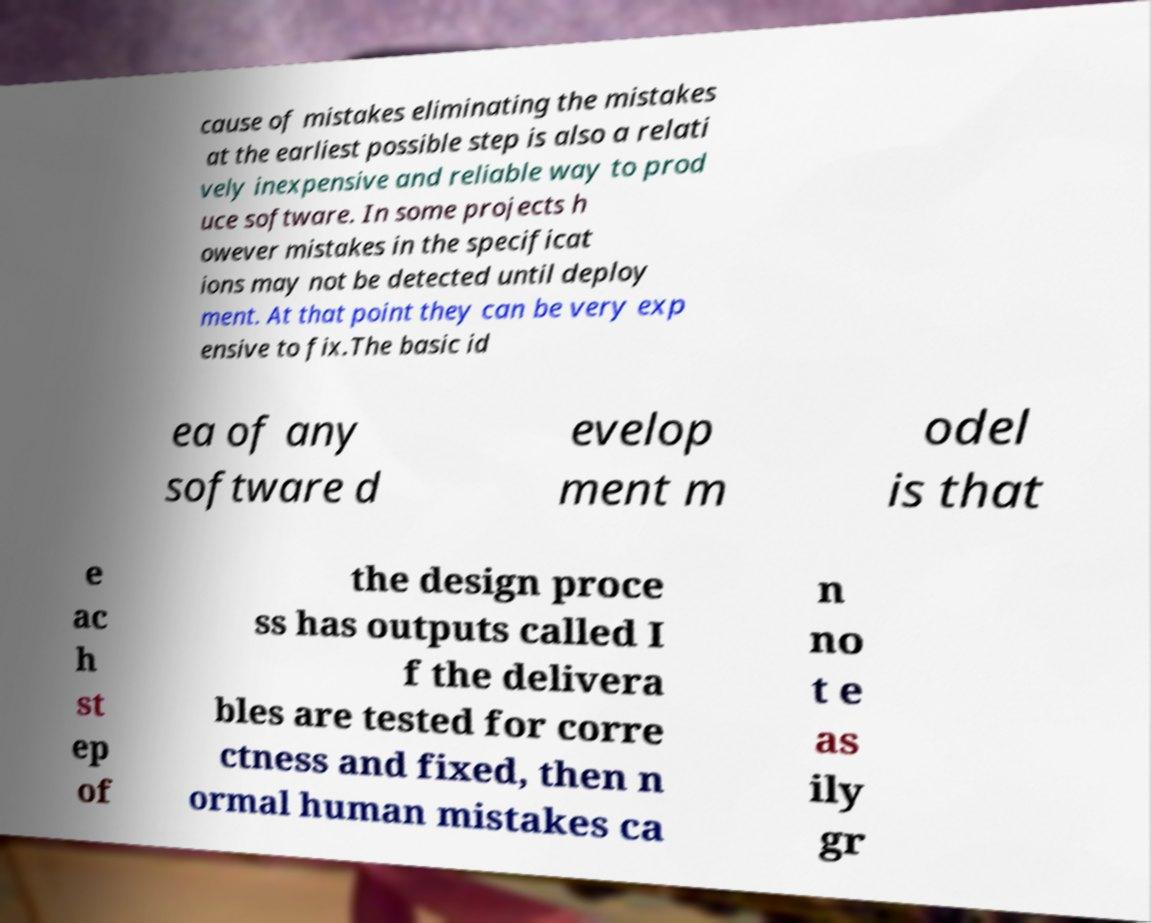I need the written content from this picture converted into text. Can you do that? cause of mistakes eliminating the mistakes at the earliest possible step is also a relati vely inexpensive and reliable way to prod uce software. In some projects h owever mistakes in the specificat ions may not be detected until deploy ment. At that point they can be very exp ensive to fix.The basic id ea of any software d evelop ment m odel is that e ac h st ep of the design proce ss has outputs called I f the delivera bles are tested for corre ctness and fixed, then n ormal human mistakes ca n no t e as ily gr 